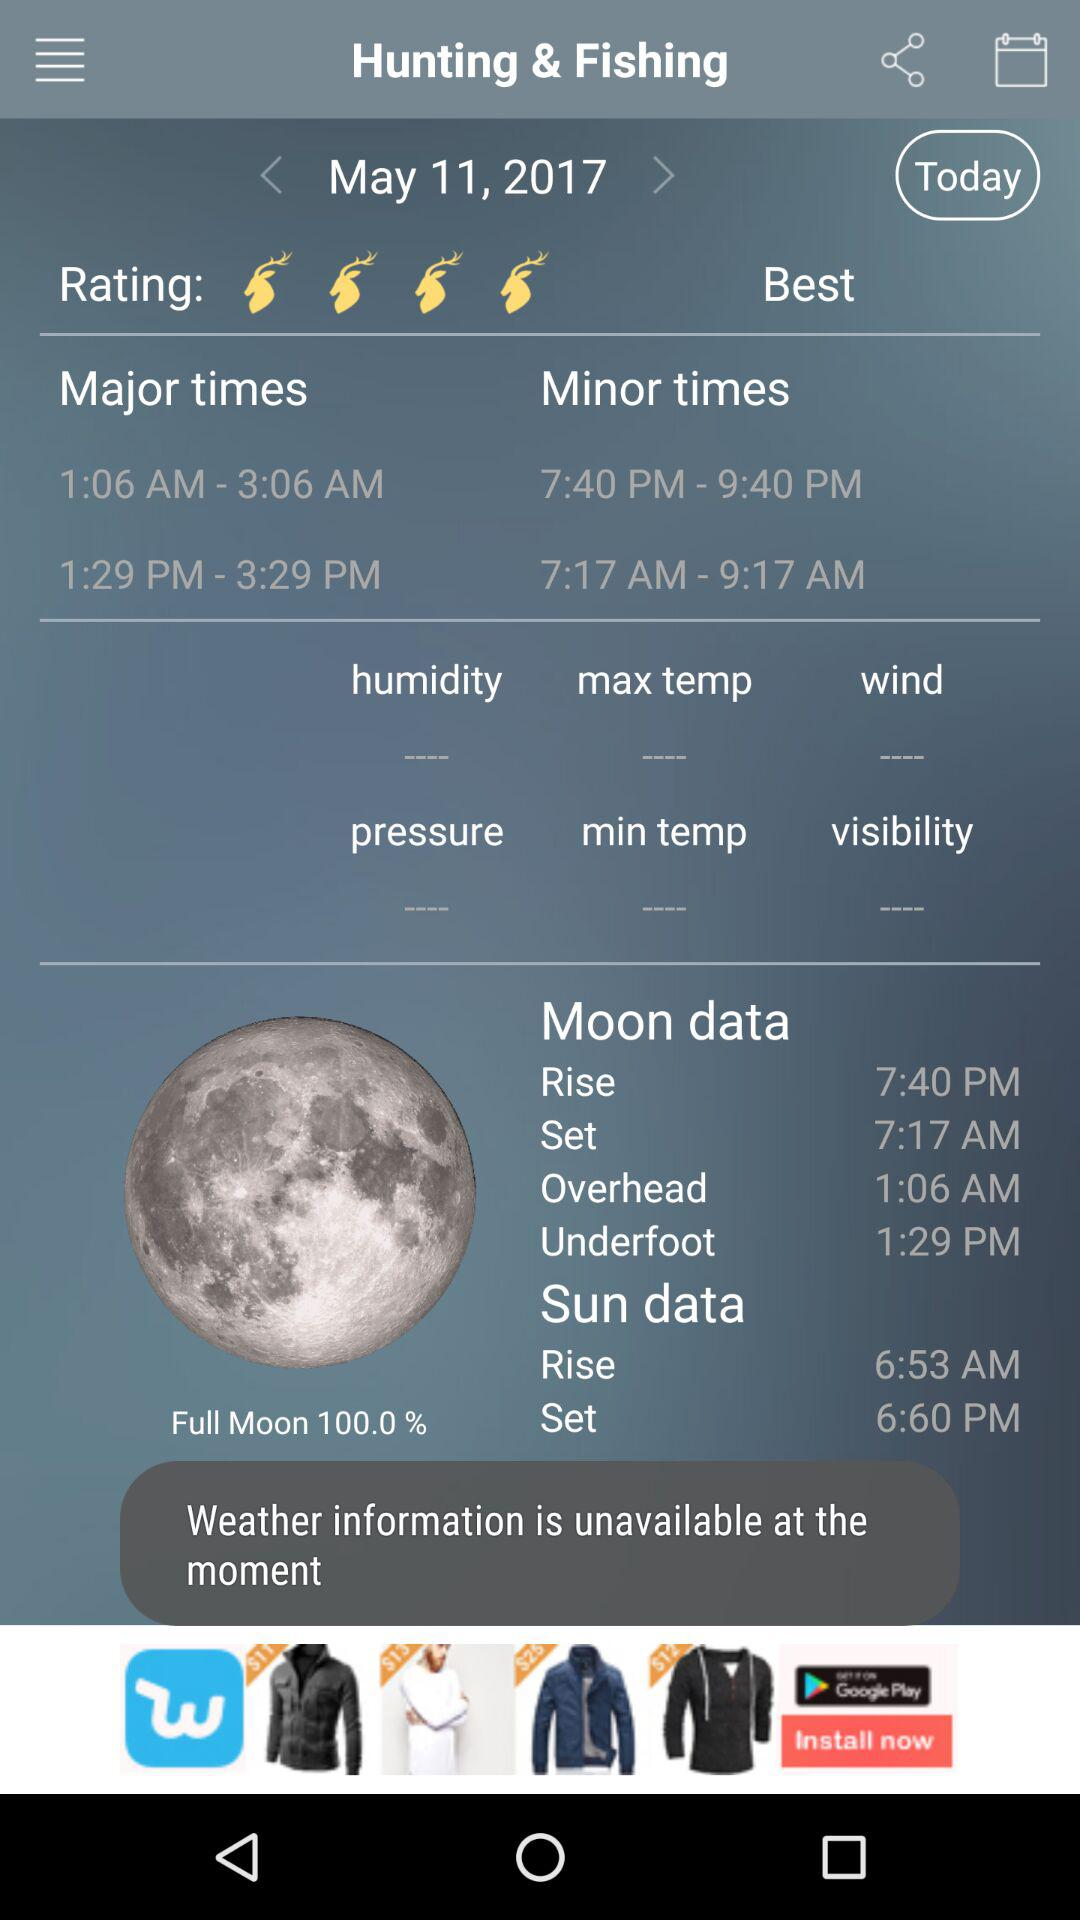What is the minor time? The minor times are 7:40 PM to 9:40 PM and 7:17 AM to 9:17 AM. 